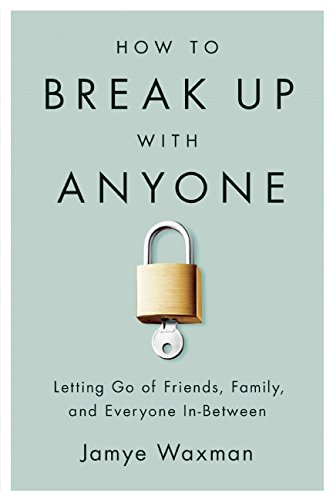What is the genre of this book? This book falls under the 'Self-Help' genre, focusing on supporting readers through emotional resolutions and personal development. 